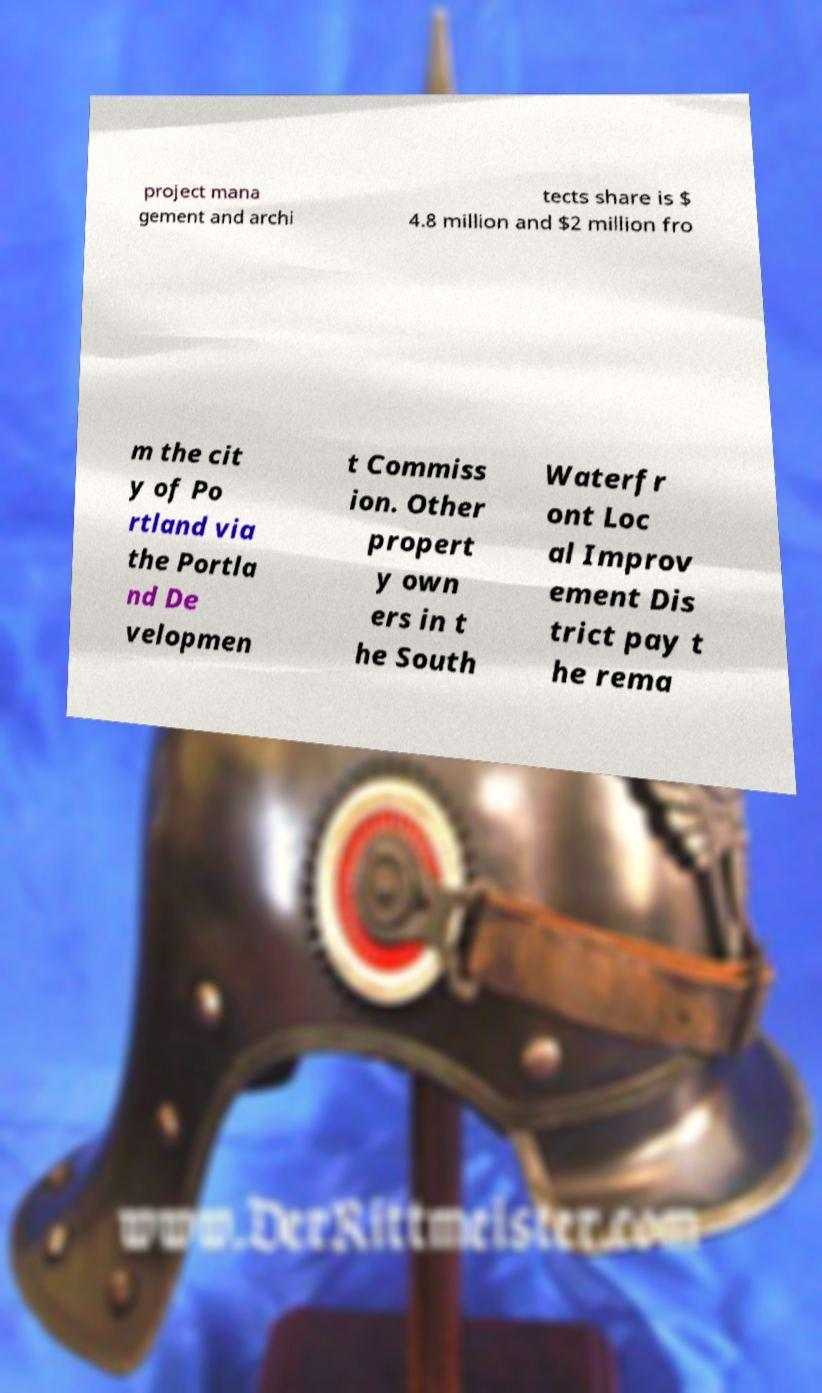I need the written content from this picture converted into text. Can you do that? project mana gement and archi tects share is $ 4.8 million and $2 million fro m the cit y of Po rtland via the Portla nd De velopmen t Commiss ion. Other propert y own ers in t he South Waterfr ont Loc al Improv ement Dis trict pay t he rema 